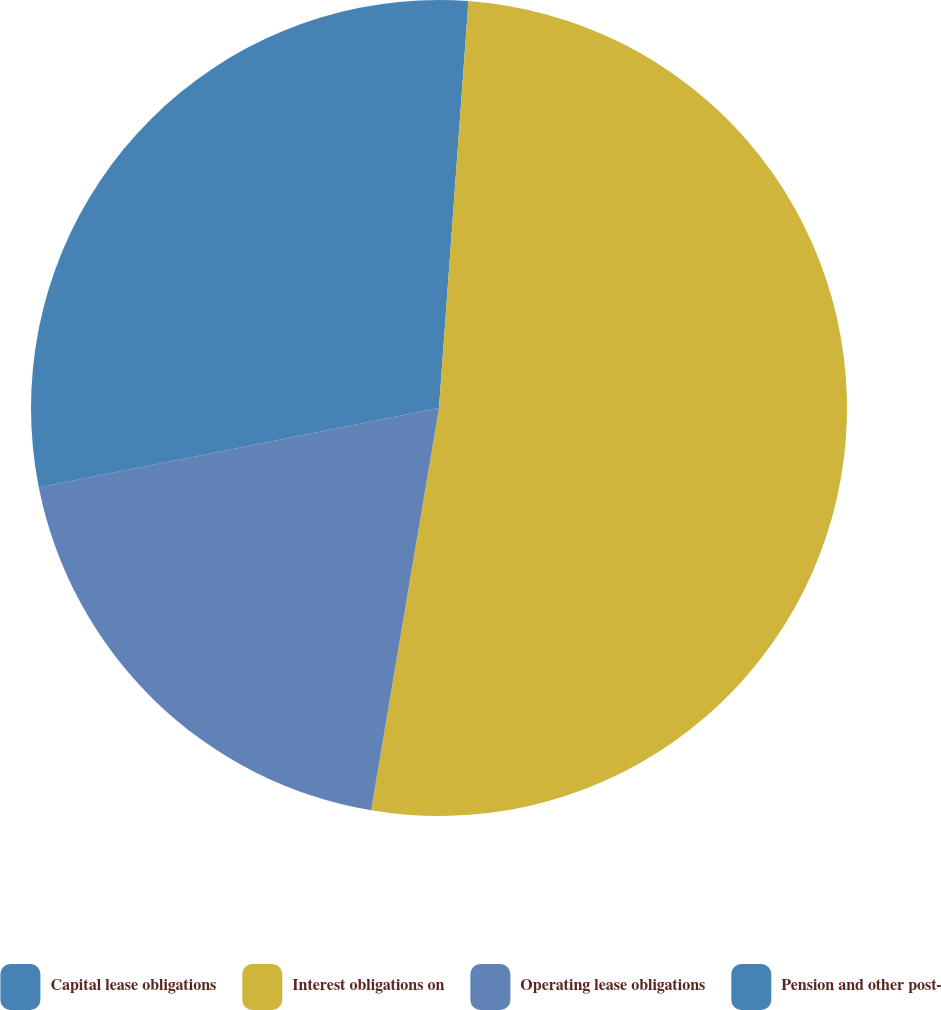Convert chart. <chart><loc_0><loc_0><loc_500><loc_500><pie_chart><fcel>Capital lease obligations<fcel>Interest obligations on<fcel>Operating lease obligations<fcel>Pension and other post-<nl><fcel>1.15%<fcel>51.51%<fcel>19.22%<fcel>28.12%<nl></chart> 